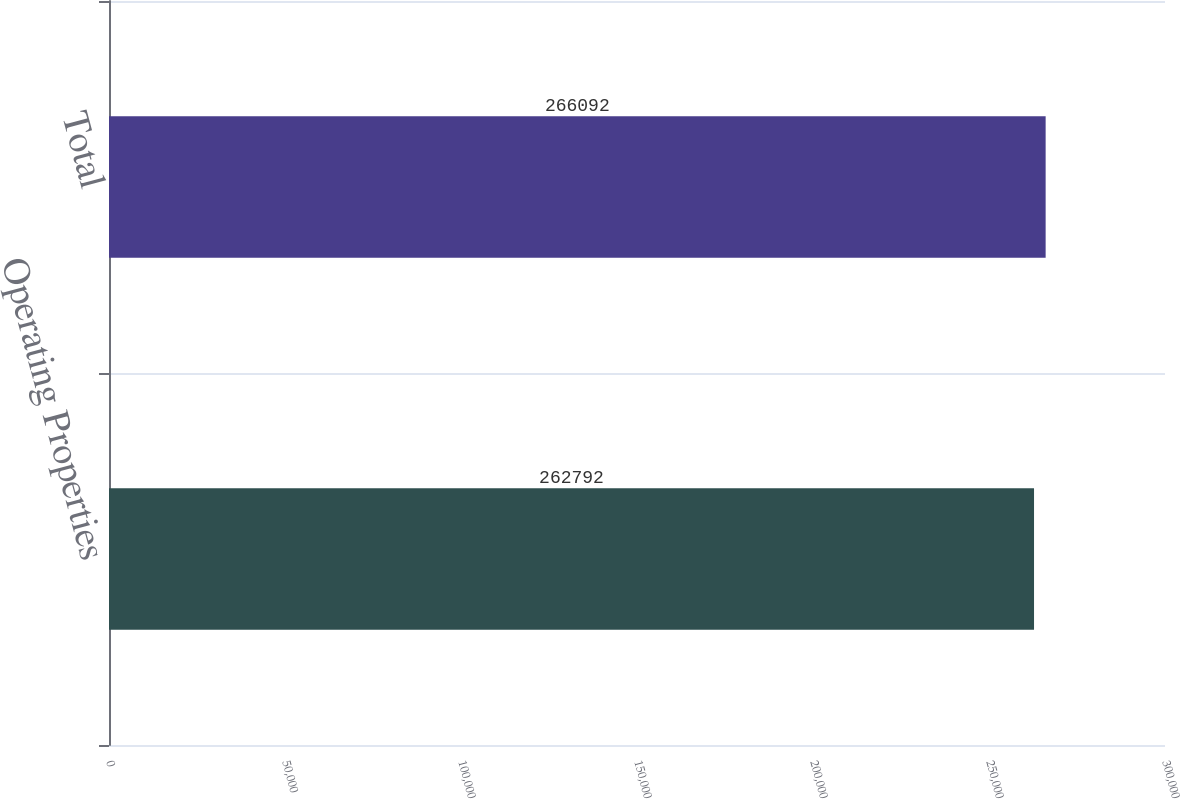<chart> <loc_0><loc_0><loc_500><loc_500><bar_chart><fcel>Operating Properties<fcel>Total<nl><fcel>262792<fcel>266092<nl></chart> 